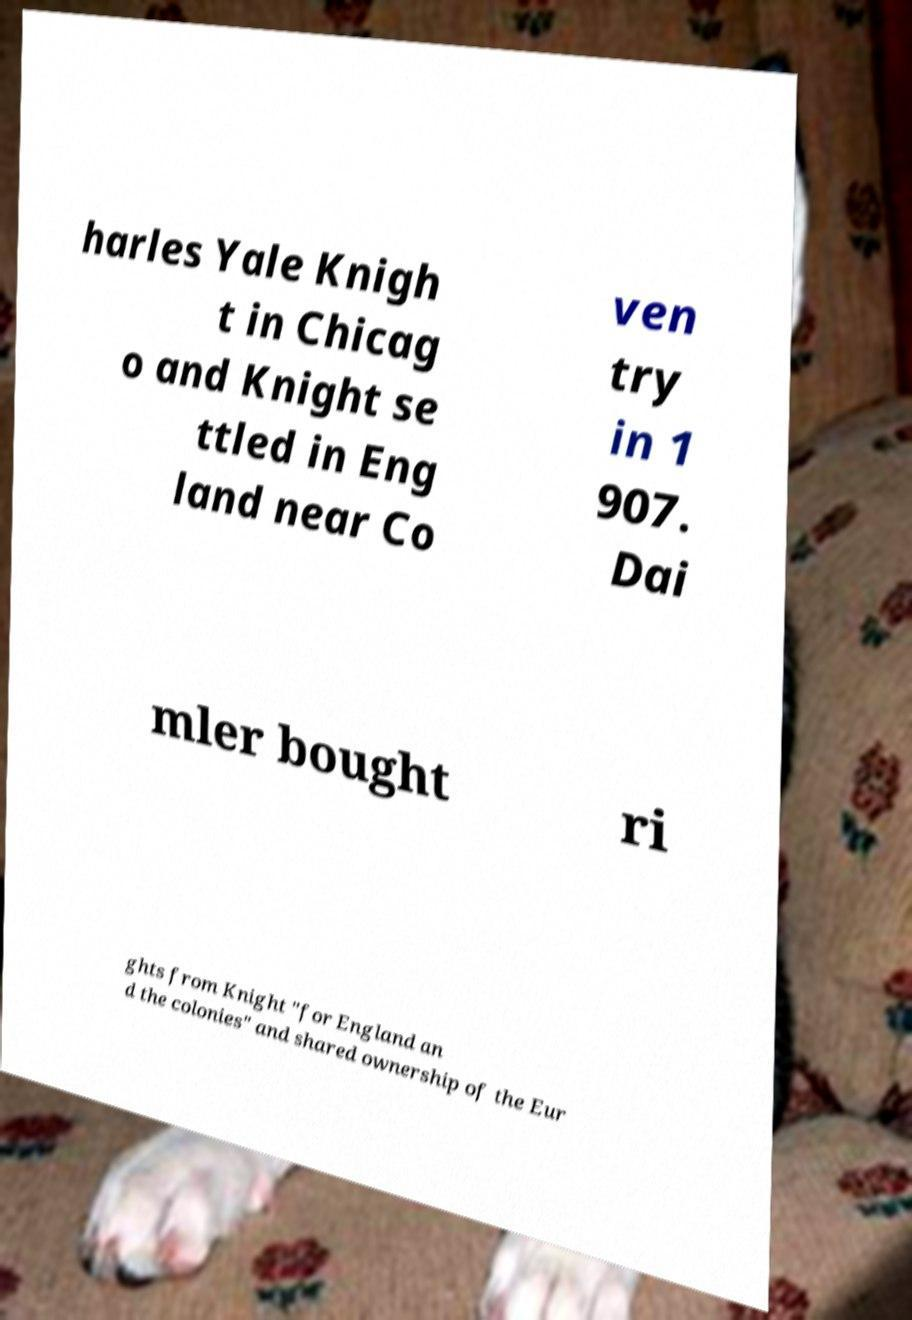Can you read and provide the text displayed in the image?This photo seems to have some interesting text. Can you extract and type it out for me? harles Yale Knigh t in Chicag o and Knight se ttled in Eng land near Co ven try in 1 907. Dai mler bought ri ghts from Knight "for England an d the colonies" and shared ownership of the Eur 